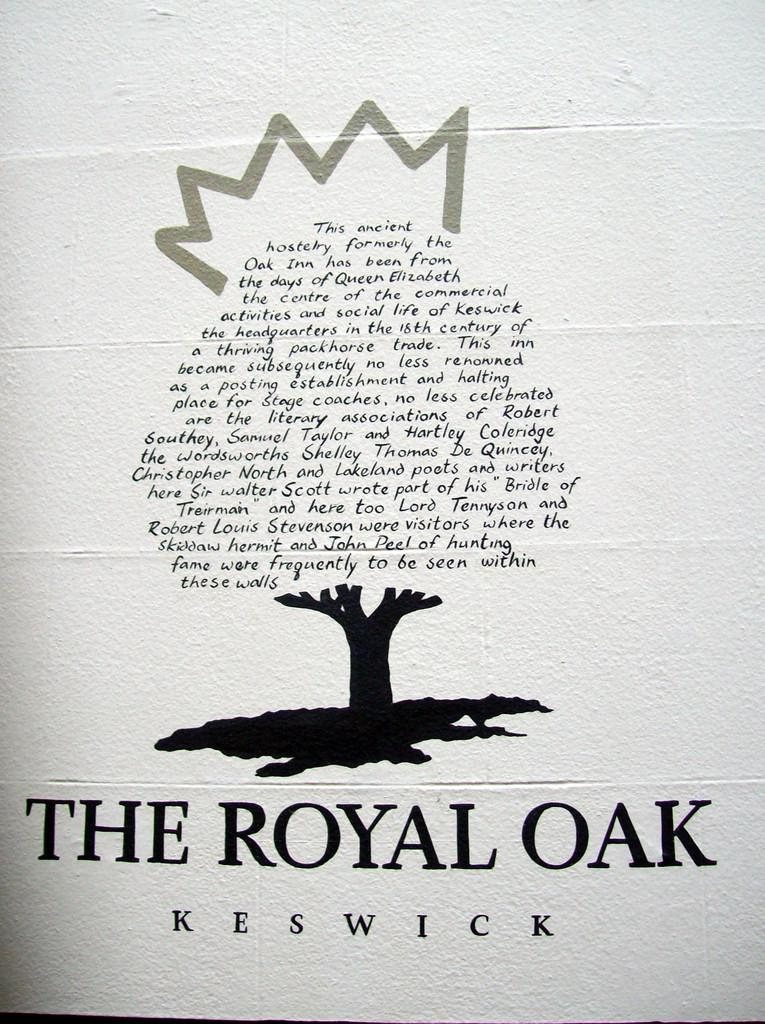<image>
Create a compact narrative representing the image presented. A sign for The Royal Oak gives information of the ancient hostelry 